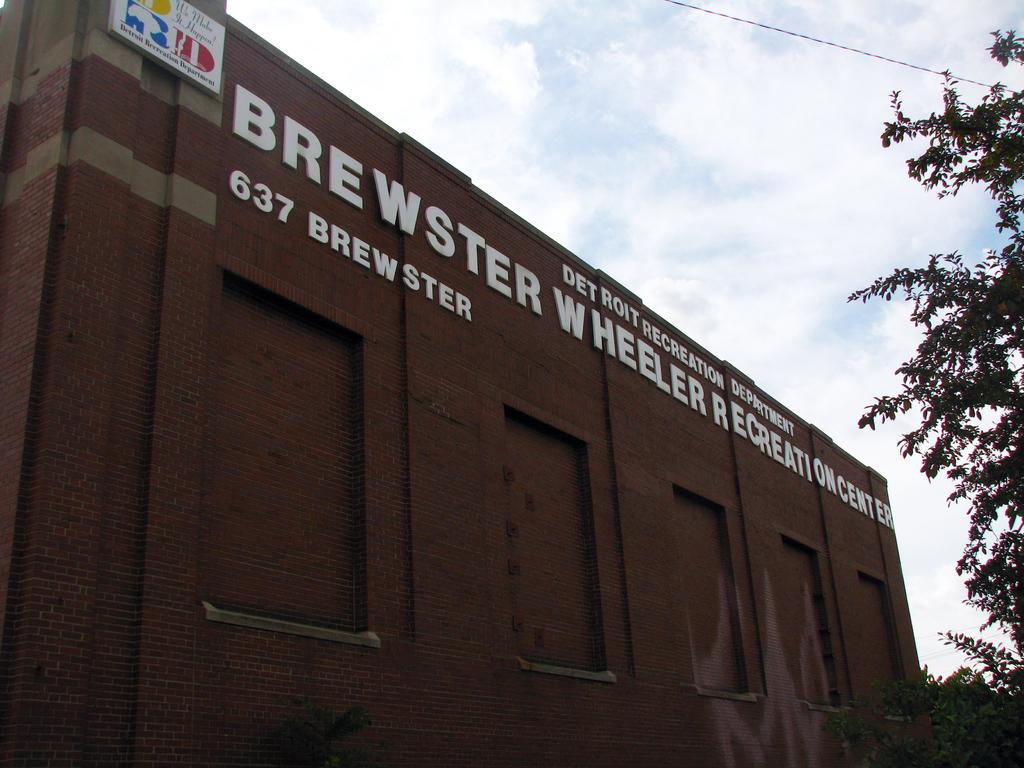What is the main structure in the center of the image? There is a building in the center of the image. What type of vegetation is on the right side of the image? There is a tree on the right side of the image. What is visible at the top of the image? The sky is visible at the top of the image. What else can be seen in the image besides the building and tree? There is a wire in the image. What color is the pie on the left side of the image? There is no pie present in the image. What type of books can be found in the library in the image? There is no library present in the image. 